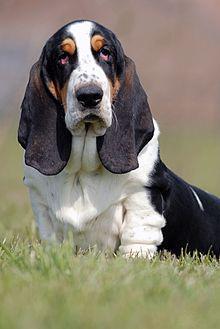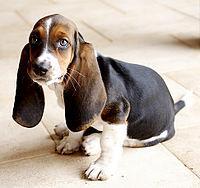The first image is the image on the left, the second image is the image on the right. Considering the images on both sides, is "One of the dogs is running in the grass." valid? Answer yes or no. No. 